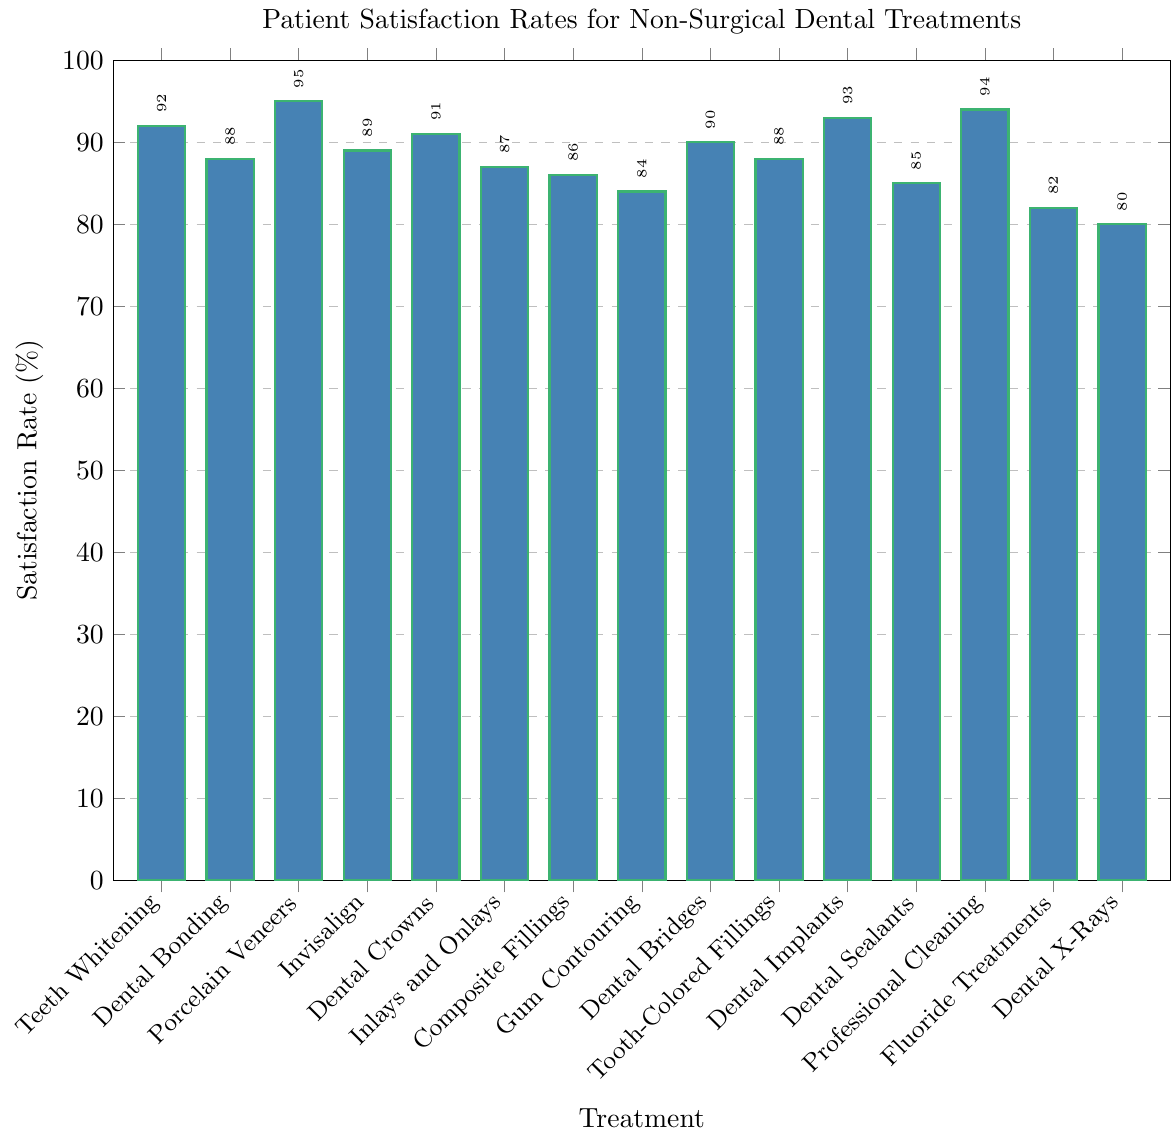What is the highest patient satisfaction rate among the treatments listed? The highest bar indicates the highest satisfaction rate. Porcelain Veneers have the tallest bar with a satisfaction rate of 95%.
Answer: 95% Which treatment has the lowest patient satisfaction rate? The shortest bar represents the lowest satisfaction rate. Dental X-Rays have the shortest bar at 80%.
Answer: Dental X-Rays Compare the satisfaction rates of Teeth Whitening and Dental Implants. Which is higher? Compare the heights of the bars for Teeth Whitening and Dental Implants. Dental Implants have a satisfaction rate of 93%, which is higher than Teeth Whitening's 92%.
Answer: Dental Implants What is the difference in satisfaction rates between Professional Cleaning and Gum Contouring? Subtract the satisfaction rate of Gum Contouring (84%) from that of Professional Cleaning (94%). 94 - 84 = 10
Answer: 10% Which treatments have a patient satisfaction rate of 88%? Look for bars corresponding to the satisfaction rate of 88%. Both Dental Bonding and Tooth-Colored Fillings have satisfaction rates of 88%.
Answer: Dental Bonding, Tooth-Colored Fillings What is the average satisfaction rate of the treatments with rates above 90%? Add the satisfaction rates of Porcelain Veneers (95), Dental Implants (93), Professional Cleaning (94), Teeth Whitening (92), and Dental Crowns (91), then divide by the number of these treatments: (95 + 93 + 94 + 92 + 91) / 5 = 93
Answer: 93% How many treatments have a satisfaction rate below 85%? Count the bars with satisfaction rates below 85%: Gum Contouring (84%), Fluoride Treatments (82%), and Dental X-Rays (80%). There are 3 treatments in total.
Answer: 3 Which two treatments have the closest satisfaction rates? Identify pairs of treatments with the nearest satisfaction rates: Dental Bonding and Tooth-Colored Fillings both have rates of 88%, and Invisalign is very close with 89%. This makes the closest pair Dental Bonding and Tooth-Colored Fillings.
Answer: Dental Bonding, Tooth-Colored Fillings Which treatments have a satisfaction rate of 10% more than Dental Sealants? Add 10% to the satisfaction rate of Dental Sealants (85% + 10% = 95%). Porcelain Veneers match this rate.
Answer: Porcelain Veneers What is the total satisfaction rate for Inlays and Onlays and Composite Fillings combined? Add the satisfaction rates of Inlays and Onlays (87%) and Composite Fillings (86%). 87 + 86 = 173
Answer: 173% 